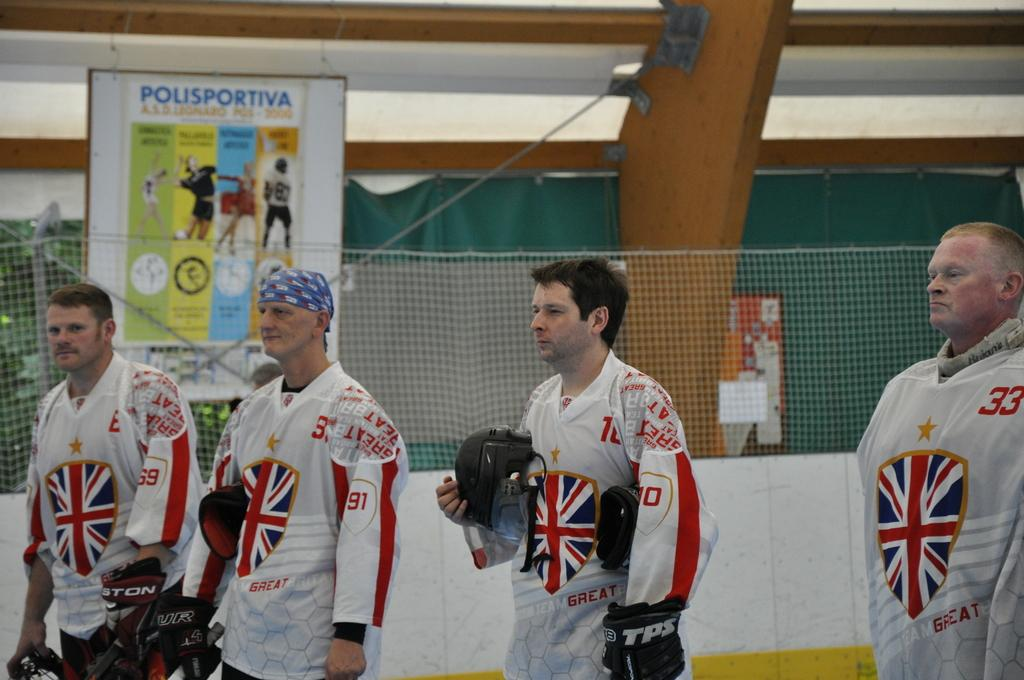Who or what can be seen in the image? There are people in the image. What object is present that is typically used for catching or hitting a ball? There is a net in the image. What type of decorative items are visible in the image? There are posters in the image. What material is the wooden object made of? The wooden object in the image is made of wood. What color is the curtain in the background of the image? There is a green curtain in the background of the image. Can you tell me who the creator of the goldfish is in the image? There are no goldfish present in the image. 